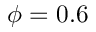Convert formula to latex. <formula><loc_0><loc_0><loc_500><loc_500>\phi = 0 . 6</formula> 